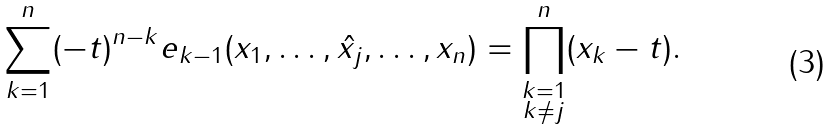Convert formula to latex. <formula><loc_0><loc_0><loc_500><loc_500>\sum _ { k = 1 } ^ { n } ( - t ) ^ { n - k } e _ { k - 1 } ( x _ { 1 } , \dots , \hat { x _ { j } } , \dots , x _ { n } ) = \prod _ { \substack { k = 1 \\ k \neq j } } ^ { n } ( x _ { k } - t ) .</formula> 